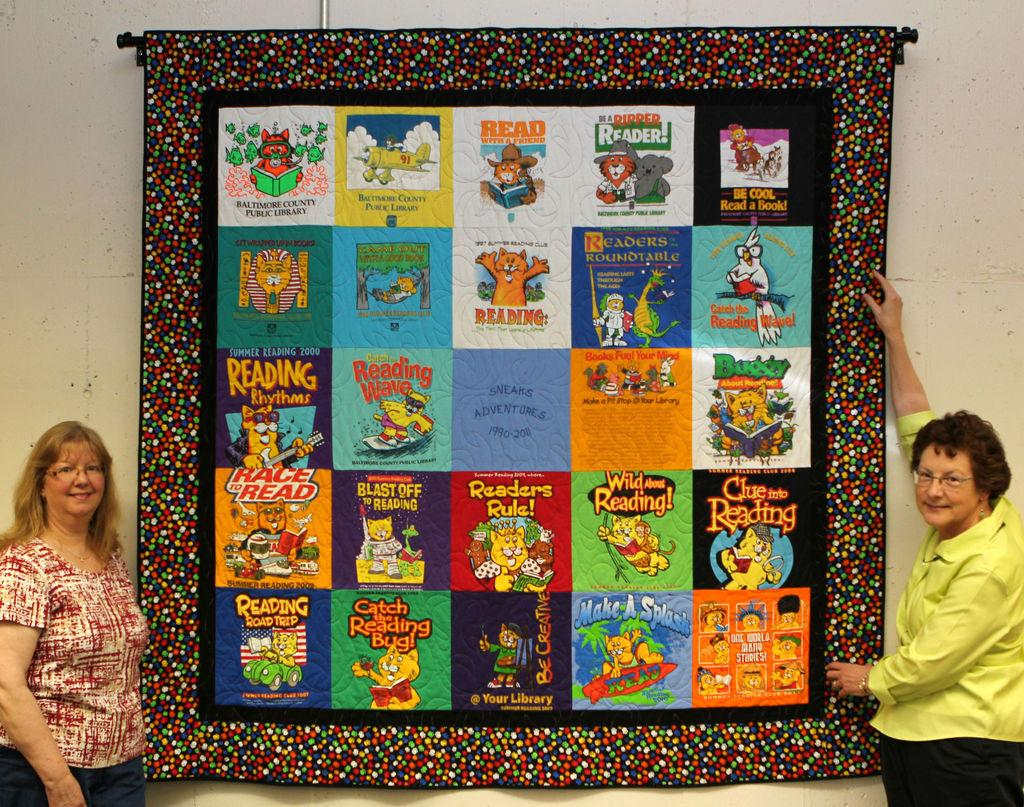How many people are in the image? There are two women in the image. What are the women wearing on their faces? The women are wearing spectacles. What can be seen on the wall in the image? There is a patchwork on the wall in the image. How many pigs are visible in the image? There are no pigs present in the image. What type of sticks are being used by the women in the image? There is no indication of any sticks being used by the women in the image. 